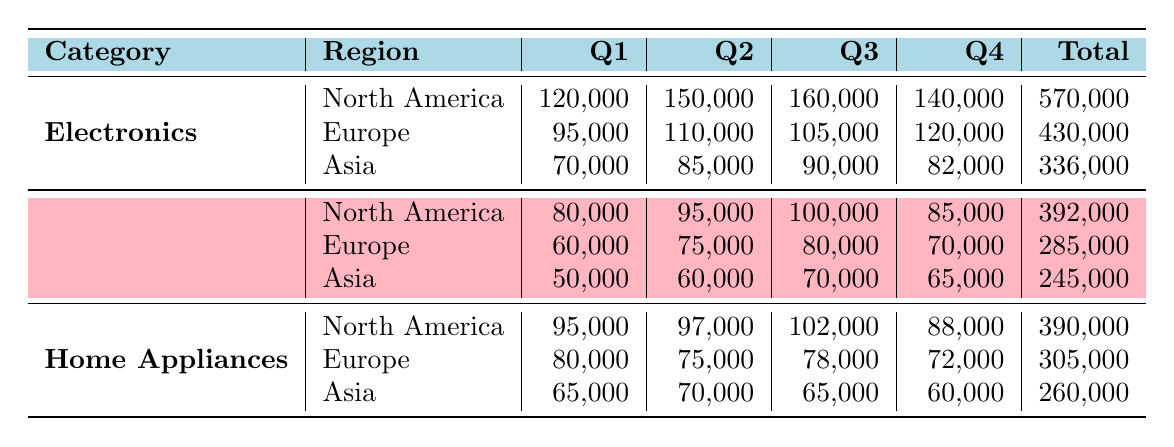What was the total sales for Electronics in North America? The total sales for Electronics in North America is listed directly in the table under the "Total" column for that category and region, which shows 570,000.
Answer: 570,000 Which region had the highest sales for Clothing? By comparing the total sales figures for Clothing across all regions, North America has the highest total of 392,000 when compared to Europe (285,000) and Asia (245,000).
Answer: North America What was the difference in total sales between Home Appliances and Clothing in Europe? The total sales for Home Appliances in Europe is 305,000, and for Clothing, it is 285,000. The difference is calculated as 305,000 - 285,000 = 20,000.
Answer: 20,000 Is it true that Asia had the lowest total sales across all categories? To assess this, we compare the total sales figures for each category in Asia: Electronics (336,000), Clothing (245,000), and Home Appliances (260,000). The highest total of 336,000 for Electronics means Asia does not have the lowest total, which belongs to Clothing (245,000). However, Asia's total for all categories is indeed lower than that of North America or Europe. Thus, the statement is true regarding categories.
Answer: Yes What is the average sale for each quarter in Asia for Electronics? The quarterly sales for Electronics in Asia are as follows: Q1 is 70,000, Q2 is 85,000, Q3 is 90,000, and Q4 is 82,000. To find the average, sum these values: 70,000 + 85,000 + 90,000 + 82,000 = 327,000. Then divide by the number of quarters, which is 4: 327,000 / 4 = 81,750.
Answer: 81,750 What was the total sales for all regions in Q3 for Home Appliances? We look at the Q3 sales for Home Appliances in each region: North America (102,000), Europe (78,000), and Asia (65,000). Adding these gives 102,000 + 78,000 + 65,000 = 245,000.
Answer: 245,000 Was the total for Clothing in Asia higher than the total for Electronics in Europe? The total for Clothing in Asia is 245,000 while the total for Electronics in Europe is 430,000. This indicates Clothing in Asia is not higher than Electronics in Europe as 245,000 is less than 430,000.
Answer: No Which product category had the overall highest total sales across all regions combined? To find this, we add the total sales for each category across all regions. Electronics: 570,000 (NA) + 430,000 (EU) + 336,000 (Asia) = 1,336,000. Clothing: 392,000 (NA) + 285,000 (EU) + 245,000 (Asia) = 922,000. Home Appliances: 390,000 (NA) + 305,000 (EU) + 260,000 (Asia) = 955,000. Electronics has the highest total of 1,336,000.
Answer: Electronics 